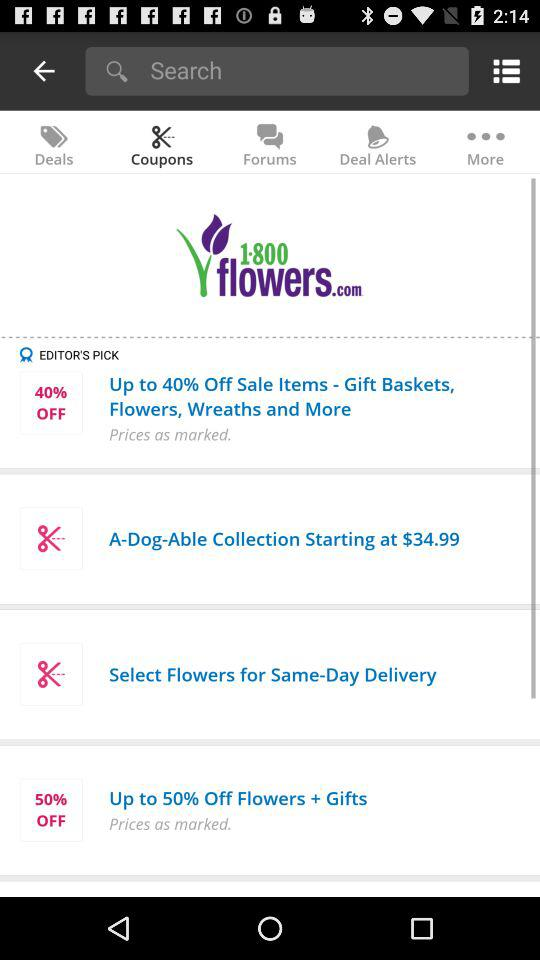What is the company name? The company name is "1-800-Flowers.com". 